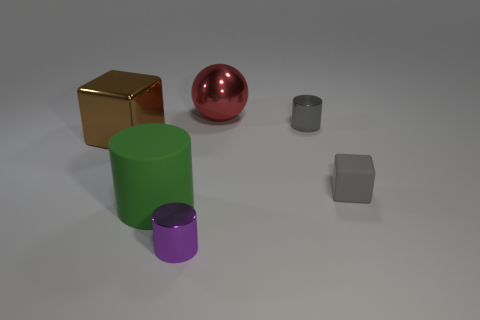What size is the other matte thing that is the same shape as the big brown object?
Offer a terse response. Small. There is a cylinder that is behind the big metallic object to the left of the metal cylinder in front of the small gray block; what color is it?
Ensure brevity in your answer.  Gray. Does the sphere have the same material as the small purple thing?
Make the answer very short. Yes. There is a cube that is right of the small thing that is in front of the gray matte object; are there any things in front of it?
Your response must be concise. Yes. Do the big matte object and the big ball have the same color?
Give a very brief answer. No. Are there fewer big matte cylinders than tiny cyan cylinders?
Give a very brief answer. No. Are the large thing on the left side of the green thing and the cylinder that is behind the big rubber cylinder made of the same material?
Offer a very short reply. Yes. Is the number of metallic cylinders right of the small gray metallic object less than the number of large brown shiny objects?
Keep it short and to the point. Yes. How many gray cylinders are on the right side of the small metallic thing that is in front of the gray metallic thing?
Make the answer very short. 1. There is a metal thing that is both behind the brown object and in front of the metal sphere; how big is it?
Make the answer very short. Small. 